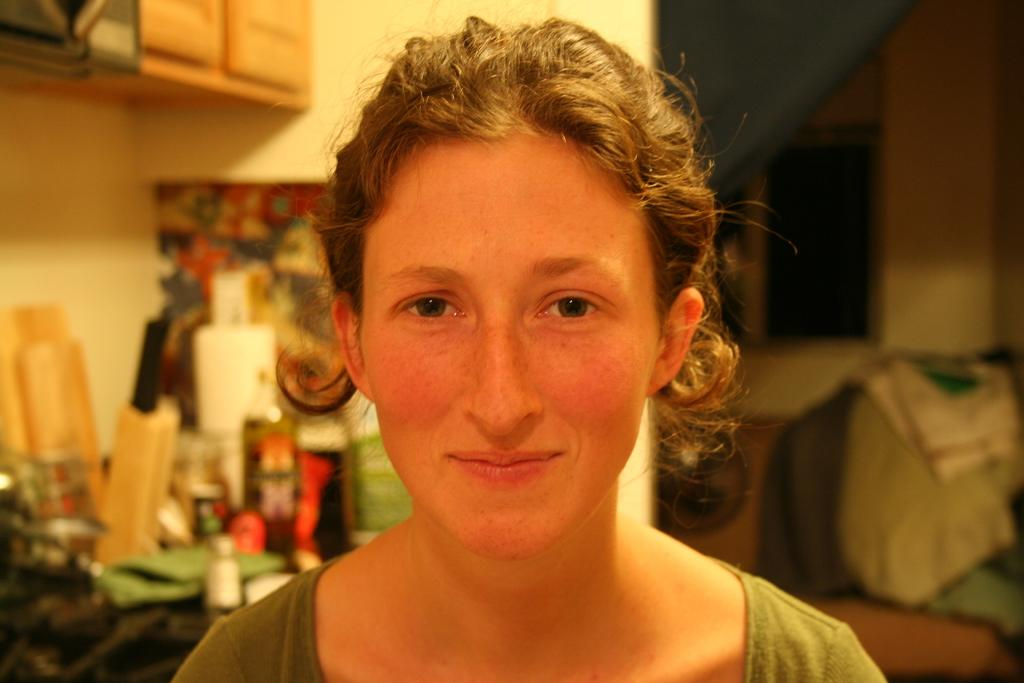What is the person in the image doing? There is a person sitting in the image. What can be seen in the background of the image? There is a wall in the background of the image. What is attached to the wall in the image? There is a cupboard attached to the wall. How would you describe the clarity of the objects in the image? The objects in the image appear blurry. Are there any mice running on the slope in the image? There is no slope or mice present in the image. 